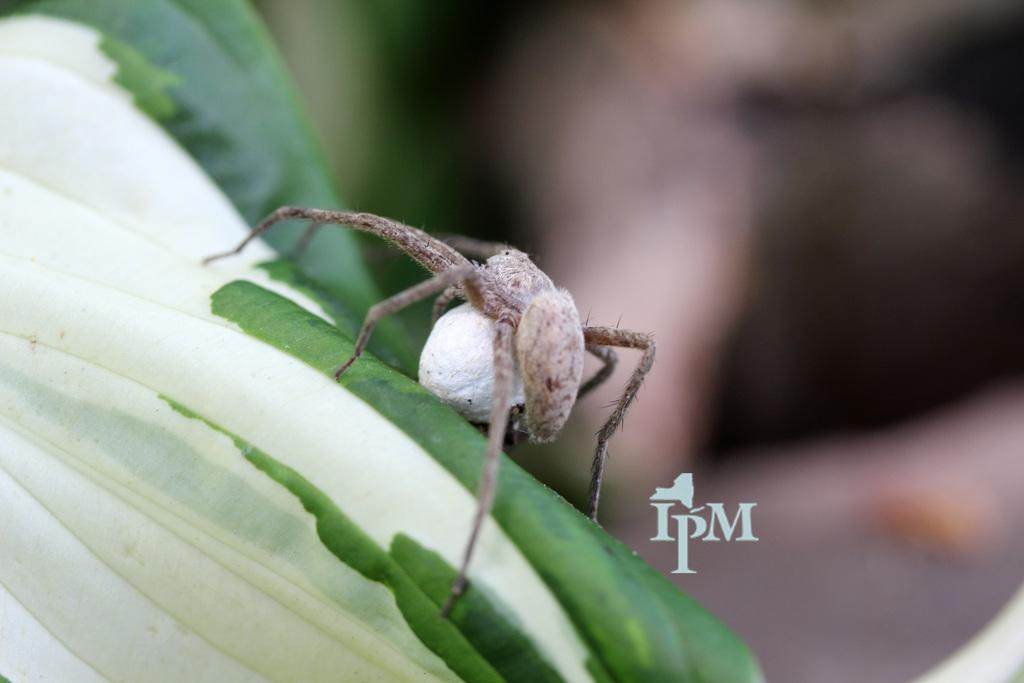What is on the leaf in the image? There is an insect on a leaf in the image. What can be observed about the background of the image? The background of the image is blurred. Is there any text present in the image? Yes, there is text written at the bottom of the image. What scent can be detected from the sand in the image? There is no sand present in the image, so it is not possible to detect a scent from it. 